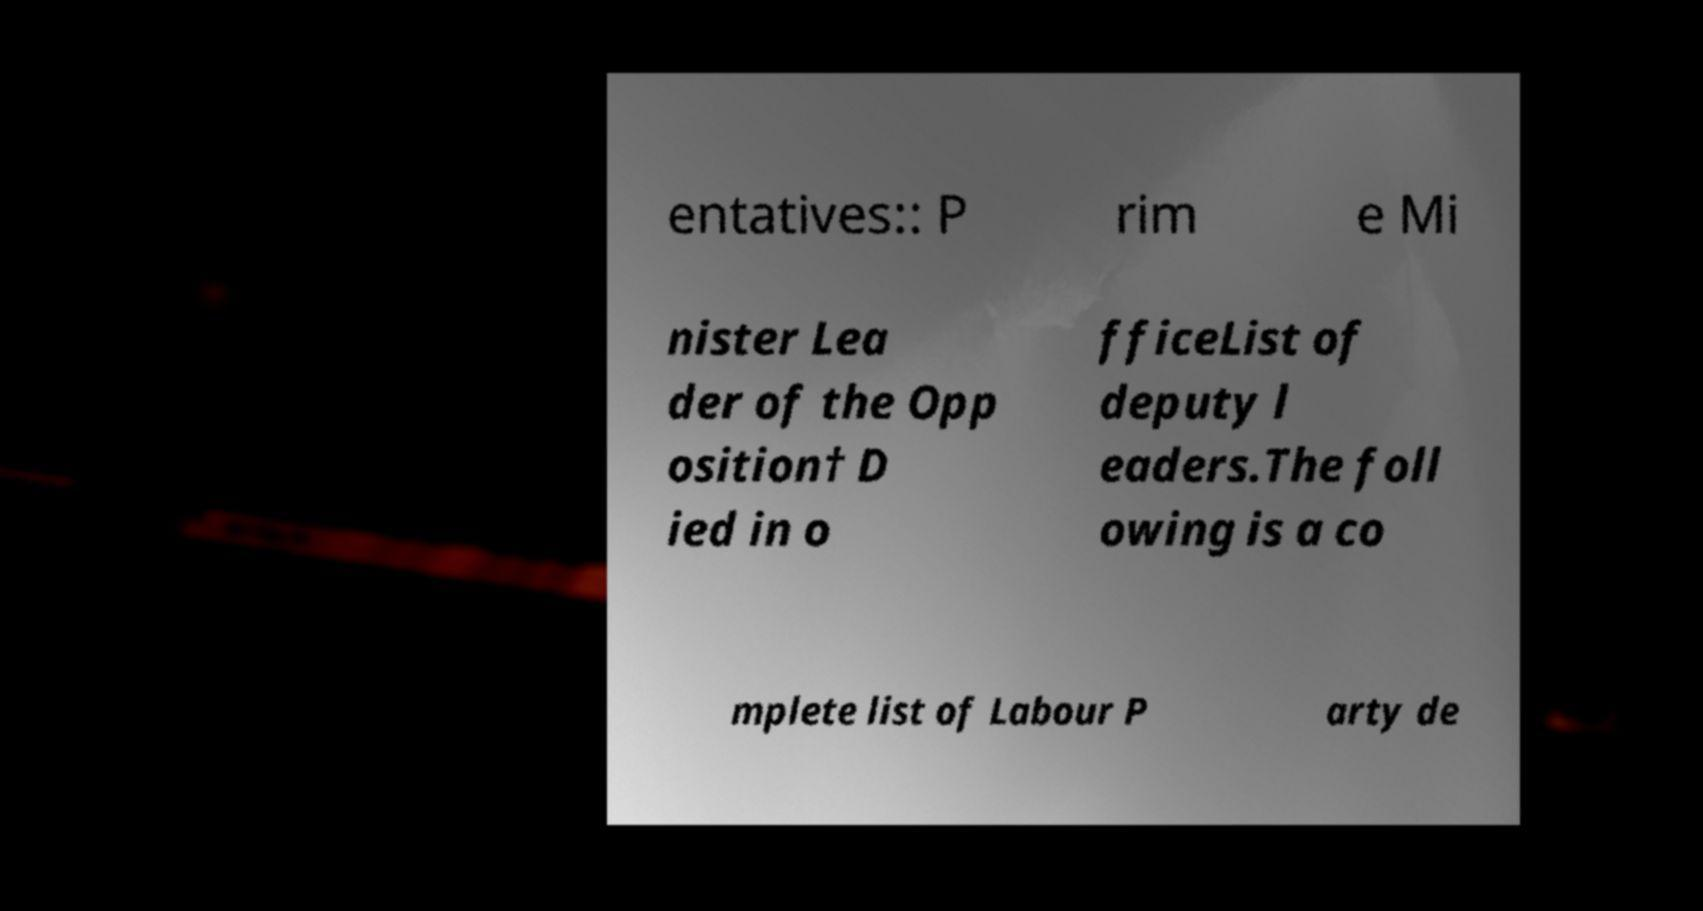Could you assist in decoding the text presented in this image and type it out clearly? entatives:: P rim e Mi nister Lea der of the Opp osition† D ied in o fficeList of deputy l eaders.The foll owing is a co mplete list of Labour P arty de 